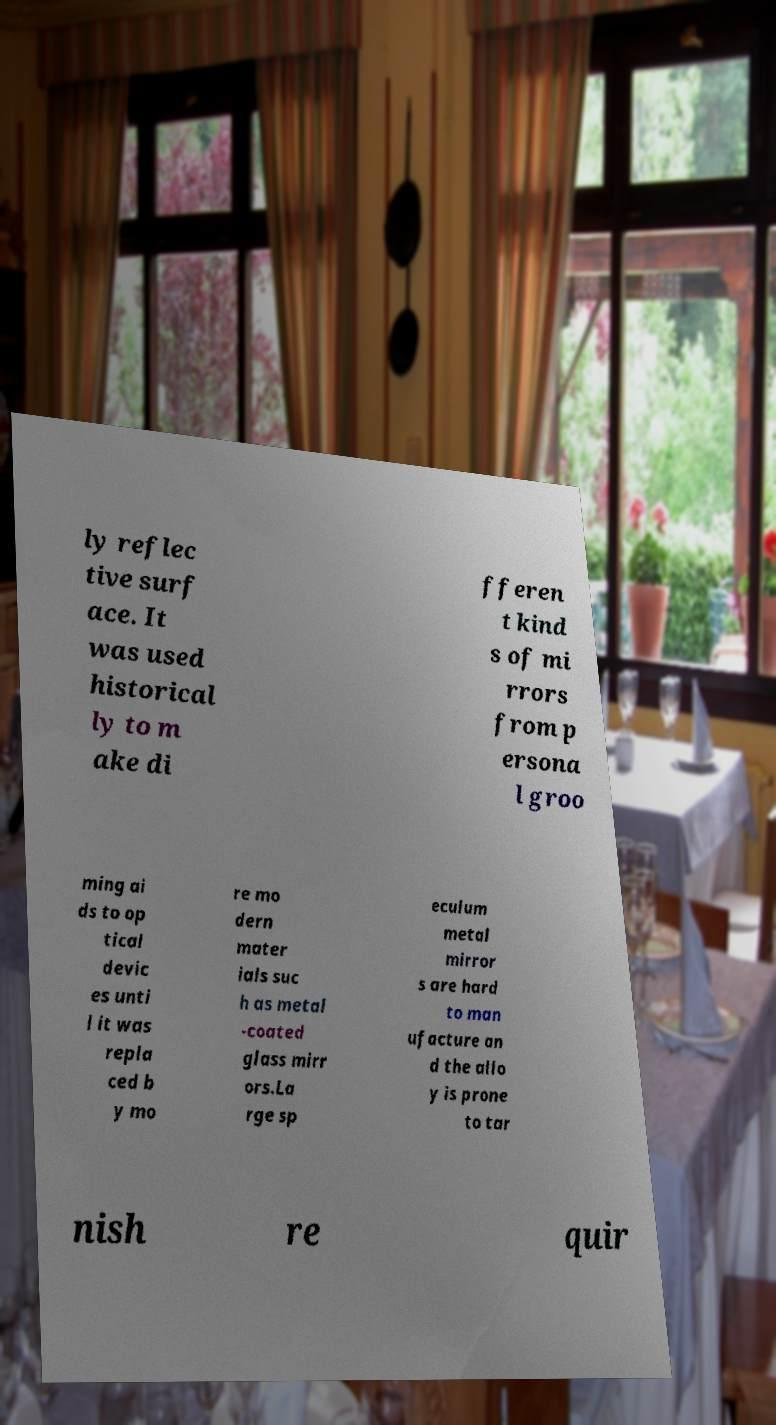What messages or text are displayed in this image? I need them in a readable, typed format. ly reflec tive surf ace. It was used historical ly to m ake di fferen t kind s of mi rrors from p ersona l groo ming ai ds to op tical devic es unti l it was repla ced b y mo re mo dern mater ials suc h as metal -coated glass mirr ors.La rge sp eculum metal mirror s are hard to man ufacture an d the allo y is prone to tar nish re quir 